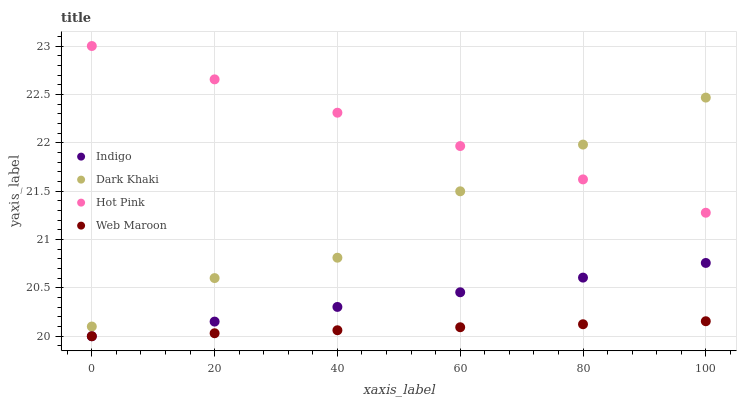Does Web Maroon have the minimum area under the curve?
Answer yes or no. Yes. Does Hot Pink have the maximum area under the curve?
Answer yes or no. Yes. Does Hot Pink have the minimum area under the curve?
Answer yes or no. No. Does Web Maroon have the maximum area under the curve?
Answer yes or no. No. Is Hot Pink the smoothest?
Answer yes or no. Yes. Is Dark Khaki the roughest?
Answer yes or no. Yes. Is Web Maroon the smoothest?
Answer yes or no. No. Is Web Maroon the roughest?
Answer yes or no. No. Does Web Maroon have the lowest value?
Answer yes or no. Yes. Does Hot Pink have the lowest value?
Answer yes or no. No. Does Hot Pink have the highest value?
Answer yes or no. Yes. Does Web Maroon have the highest value?
Answer yes or no. No. Is Indigo less than Dark Khaki?
Answer yes or no. Yes. Is Dark Khaki greater than Web Maroon?
Answer yes or no. Yes. Does Dark Khaki intersect Hot Pink?
Answer yes or no. Yes. Is Dark Khaki less than Hot Pink?
Answer yes or no. No. Is Dark Khaki greater than Hot Pink?
Answer yes or no. No. Does Indigo intersect Dark Khaki?
Answer yes or no. No. 